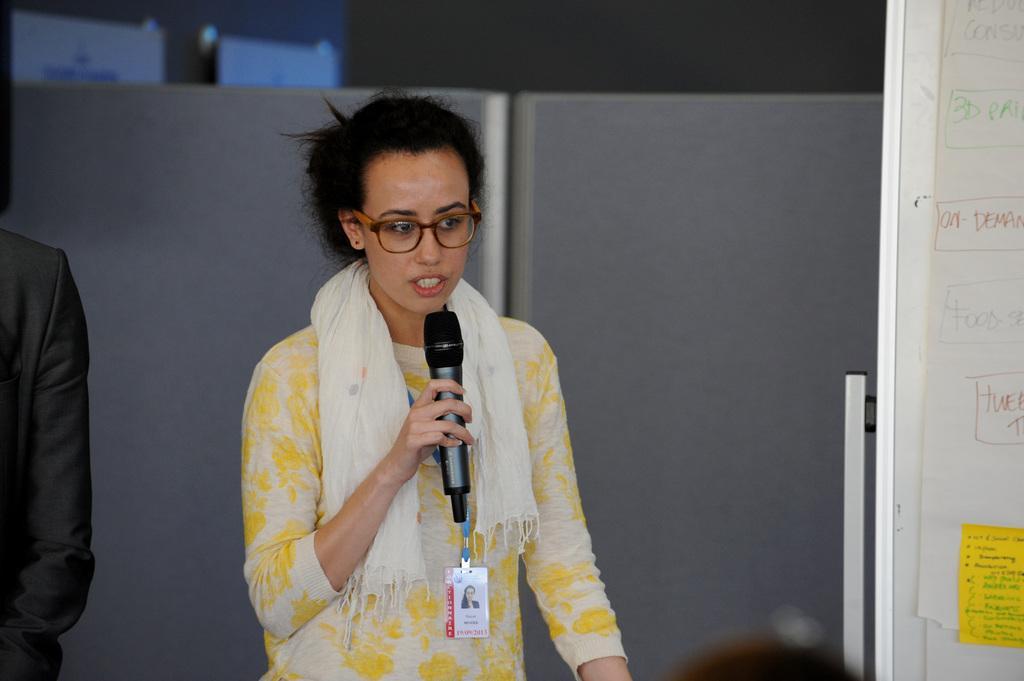Could you give a brief overview of what you see in this image? A woman wearing yellow dress, scarf, tag and specs is holding a mic and talking. Beside her another person is standing. On the right there is a board with notices. In the background there is a wall. 